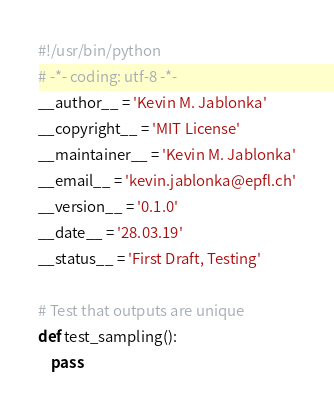Convert code to text. <code><loc_0><loc_0><loc_500><loc_500><_Python_>#!/usr/bin/python
# -*- coding: utf-8 -*-
__author__ = 'Kevin M. Jablonka'
__copyright__ = 'MIT License'
__maintainer__ = 'Kevin M. Jablonka'
__email__ = 'kevin.jablonka@epfl.ch'
__version__ = '0.1.0'
__date__ = '28.03.19'
__status__ = 'First Draft, Testing'

# Test that outputs are unique
def test_sampling():
    pass
</code> 